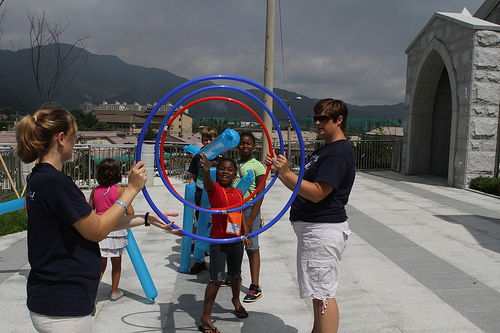<image>
Is the female next to the ring? Yes. The female is positioned adjacent to the ring, located nearby in the same general area. 